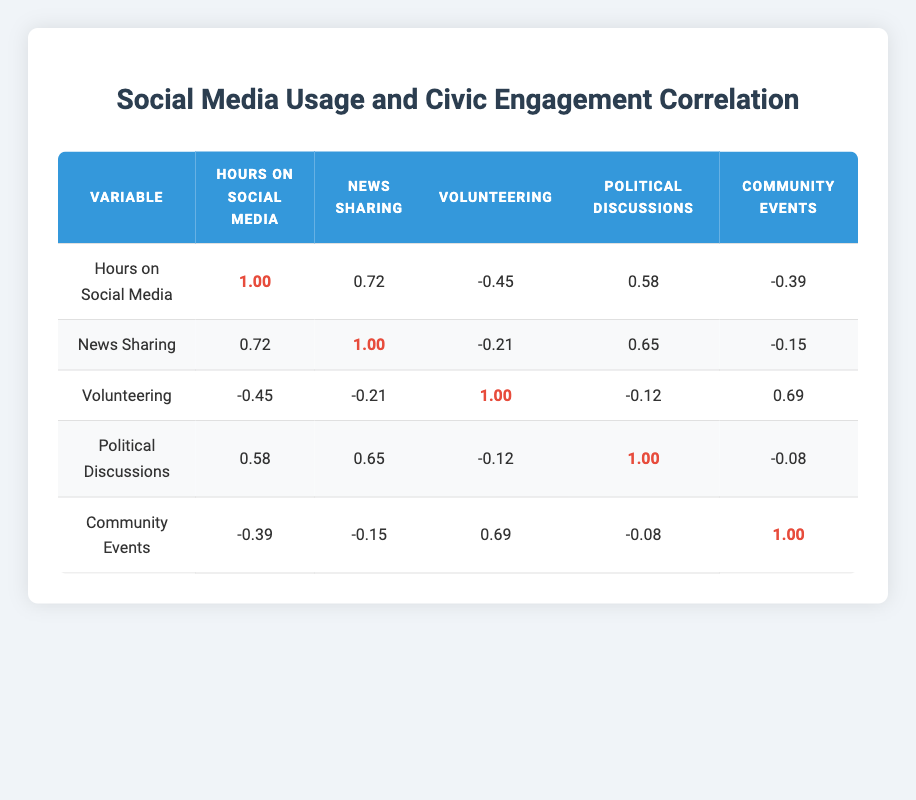What is the correlation between hours spent on social media and the frequency of news sharing? The table shows a correlation coefficient of 0.72 between hours spent on social media and the frequency of news sharing, indicating a strong positive relationship.
Answer: 0.72 Is there a negative correlation between volunteering hours per month and hours spent on social media? The correlation value is -0.45, which indicates a moderate negative correlation between volunteering hours per month and hours spent on social media.
Answer: Yes What is the correlation coefficient between news sharing and participation in political discussions? The table indicates a correlation coefficient of 0.65 between news sharing and participation in political discussions, suggesting a strong positive relationship.
Answer: 0.65 What is the relationship between volunteering hours and community event engagement? There is a correlation of 0.69 between volunteering hours and engagement in community events, indicating a strong positive relationship.
Answer: 0.69 What is the average correlation between hours spent on social media and civic engagement variables (volunteering, political discussions, community events)? The averages of the correlation coefficients for the relevant variables (volunteering: -0.45, political discussions: 0.58, community events: -0.39) are calculated as (-0.45 + 0.58 - 0.39)/3 = -0.0867, which when rounded gives an average of approximately -0.09.
Answer: -0.09 Do higher hours spent on social media lead to increased participation in political discussions? The correlation is 0.58, showing a positive but moderate relationship between hours spent on social media and participation in political discussions, suggesting they tend to increase together, but one does not necessarily lead to the other.
Answer: No What is the overall trend in the relationship between social media usage and civic engagement based on the table? Analyzing the correlation coefficients, it's evident that while some civic engagement aspects like news sharing and political discussions show positive correlations with social media use, others like volunteering hours exhibit a clear negative correlation. This indicates mixed trends in social media usage impacts on civic engagement levels.
Answer: Mixed trends What would be the consequence if a participant increased social media usage by a few hours based on the table? If social media usage increased by a few hours, we might expect increased news sharing (0.72 correlation), but potentially lowered volunteering hours (-0.45 correlation) and community event participation (-0.39 correlation). Therefore, increased social media usage could lead to varied impacts on civic engagement levels.
Answer: Varied impacts 